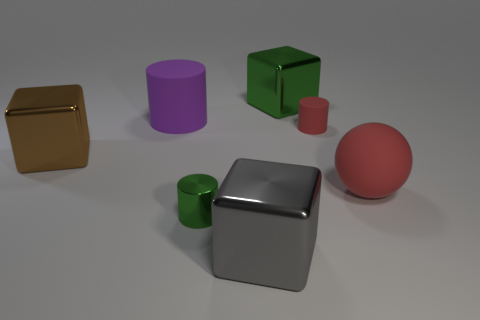Subtract all big brown cubes. How many cubes are left? 2 Subtract all red cylinders. How many cylinders are left? 2 Subtract all balls. How many objects are left? 6 Subtract 2 cylinders. How many cylinders are left? 1 Subtract all blue blocks. Subtract all cyan spheres. How many blocks are left? 3 Subtract all cyan blocks. How many green cylinders are left? 1 Subtract all big brown shiny objects. Subtract all purple objects. How many objects are left? 5 Add 7 large cubes. How many large cubes are left? 10 Add 4 big yellow shiny spheres. How many big yellow shiny spheres exist? 4 Add 1 blue objects. How many objects exist? 8 